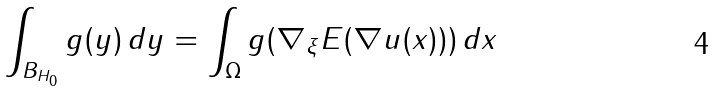Convert formula to latex. <formula><loc_0><loc_0><loc_500><loc_500>\int _ { B _ { H _ { 0 } } } g ( y ) \, d y = \int _ { \Omega } g ( \nabla _ { \xi } E ( \nabla u ( x ) ) ) \, d x</formula> 